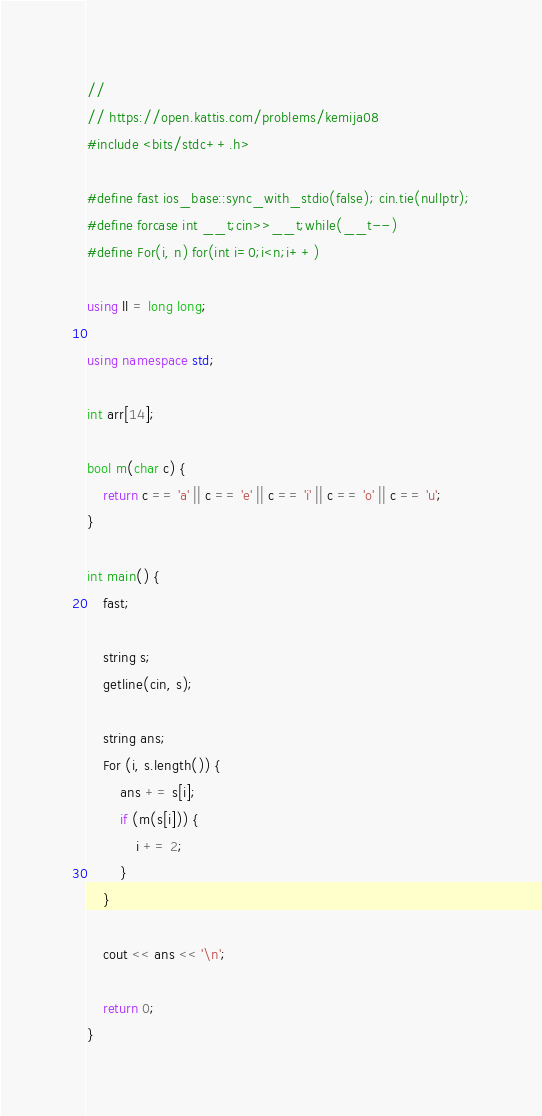<code> <loc_0><loc_0><loc_500><loc_500><_C++_>//
// https://open.kattis.com/problems/kemija08
#include <bits/stdc++.h>

#define fast ios_base::sync_with_stdio(false); cin.tie(nullptr);
#define forcase int __t;cin>>__t;while(__t--)
#define For(i, n) for(int i=0;i<n;i++)

using ll = long long;

using namespace std;

int arr[14];

bool m(char c) {
    return c == 'a' || c == 'e' || c == 'i' || c == 'o' || c == 'u';
}

int main() {
    fast;

    string s;
    getline(cin, s);
    
    string ans;
    For (i, s.length()) {
        ans += s[i];
        if (m(s[i])) {
            i += 2;
        }
    }

    cout << ans << '\n';

    return 0;
}
</code> 